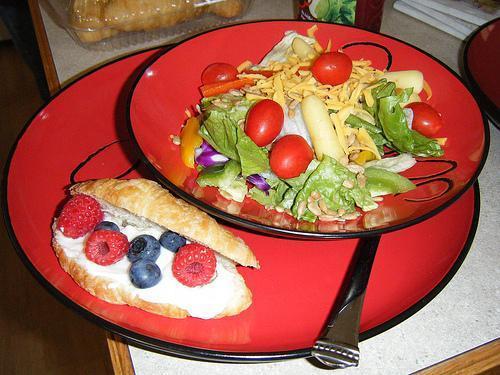How many plates are there?
Give a very brief answer. 2. 